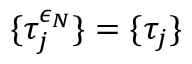Convert formula to latex. <formula><loc_0><loc_0><loc_500><loc_500>\{ \tau _ { j } ^ { \epsilon _ { N } } \} = \{ \tau _ { j } \}</formula> 